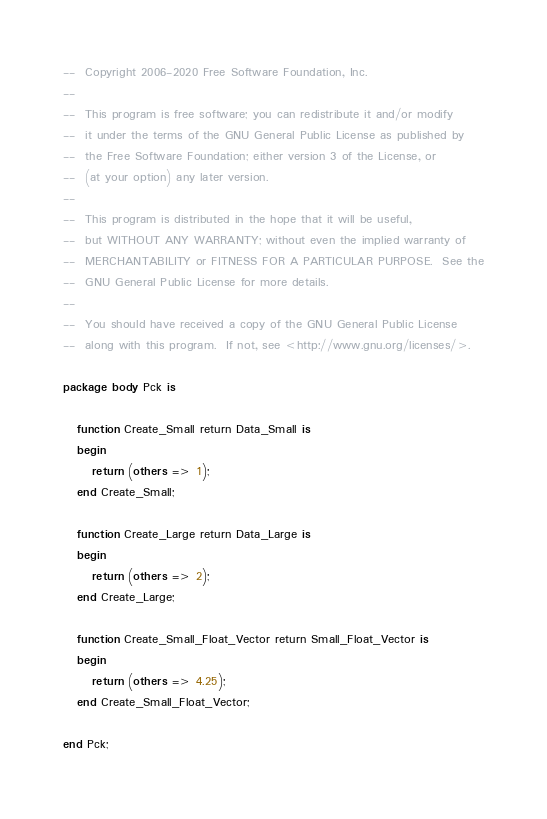Convert code to text. <code><loc_0><loc_0><loc_500><loc_500><_Ada_>--  Copyright 2006-2020 Free Software Foundation, Inc.
--
--  This program is free software; you can redistribute it and/or modify
--  it under the terms of the GNU General Public License as published by
--  the Free Software Foundation; either version 3 of the License, or
--  (at your option) any later version.
--
--  This program is distributed in the hope that it will be useful,
--  but WITHOUT ANY WARRANTY; without even the implied warranty of
--  MERCHANTABILITY or FITNESS FOR A PARTICULAR PURPOSE.  See the
--  GNU General Public License for more details.
--
--  You should have received a copy of the GNU General Public License
--  along with this program.  If not, see <http://www.gnu.org/licenses/>.

package body Pck is

   function Create_Small return Data_Small is
   begin
      return (others => 1);
   end Create_Small;

   function Create_Large return Data_Large is
   begin
      return (others => 2);
   end Create_Large;

   function Create_Small_Float_Vector return Small_Float_Vector is
   begin
      return (others => 4.25);
   end Create_Small_Float_Vector;

end Pck;
</code> 